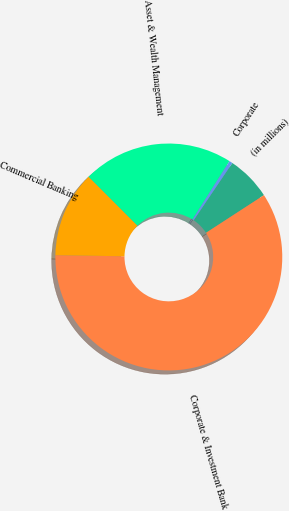Convert chart. <chart><loc_0><loc_0><loc_500><loc_500><pie_chart><fcel>(in millions)<fcel>Corporate & Investment Bank<fcel>Commercial Banking<fcel>Asset & Wealth Management<fcel>Corporate<nl><fcel>6.37%<fcel>59.42%<fcel>12.26%<fcel>21.47%<fcel>0.47%<nl></chart> 